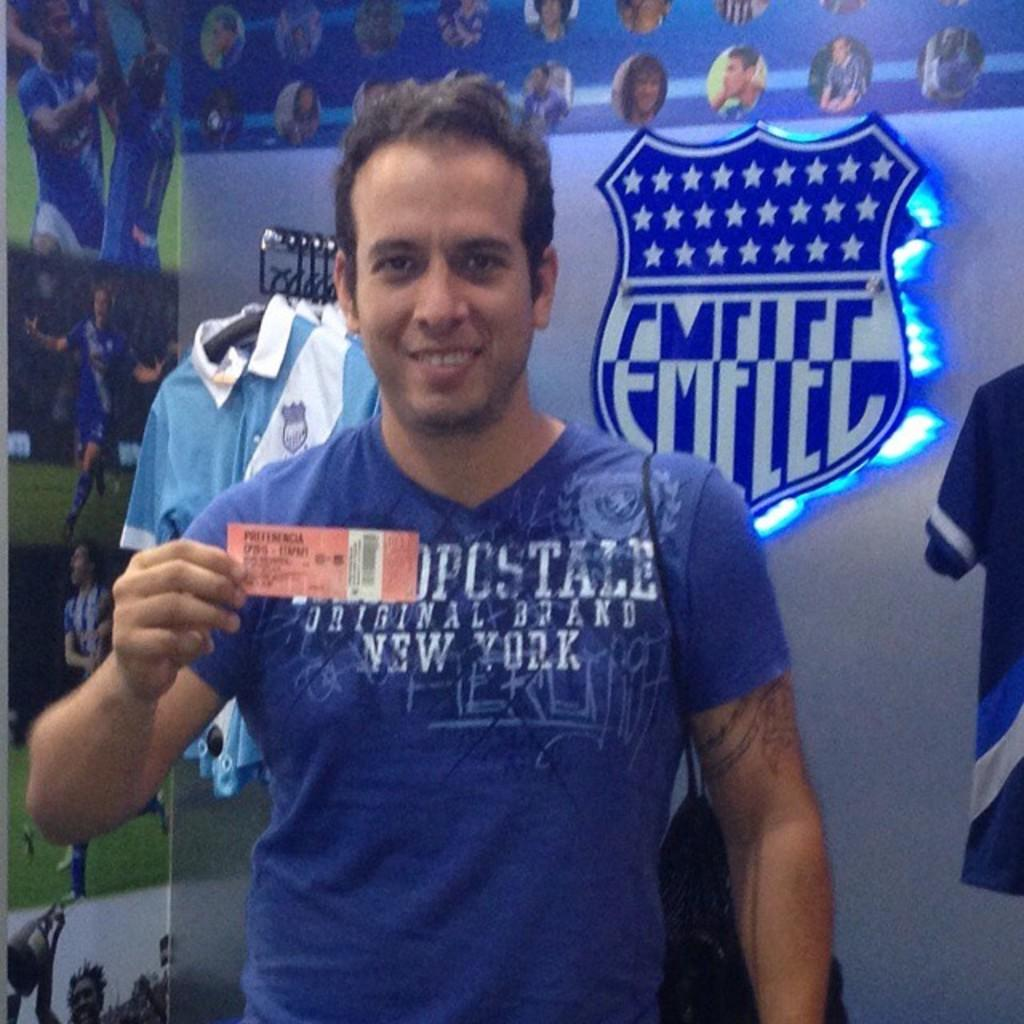Provide a one-sentence caption for the provided image. guy wearing blue shirt that has new york on it and emelec logo on wall in background. 